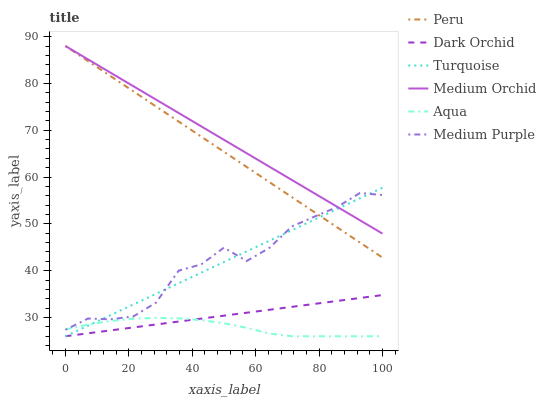Does Aqua have the minimum area under the curve?
Answer yes or no. Yes. Does Medium Orchid have the maximum area under the curve?
Answer yes or no. Yes. Does Medium Orchid have the minimum area under the curve?
Answer yes or no. No. Does Aqua have the maximum area under the curve?
Answer yes or no. No. Is Turquoise the smoothest?
Answer yes or no. Yes. Is Medium Purple the roughest?
Answer yes or no. Yes. Is Medium Orchid the smoothest?
Answer yes or no. No. Is Medium Orchid the roughest?
Answer yes or no. No. Does Turquoise have the lowest value?
Answer yes or no. Yes. Does Medium Orchid have the lowest value?
Answer yes or no. No. Does Peru have the highest value?
Answer yes or no. Yes. Does Aqua have the highest value?
Answer yes or no. No. Is Dark Orchid less than Peru?
Answer yes or no. Yes. Is Medium Orchid greater than Dark Orchid?
Answer yes or no. Yes. Does Turquoise intersect Medium Purple?
Answer yes or no. Yes. Is Turquoise less than Medium Purple?
Answer yes or no. No. Is Turquoise greater than Medium Purple?
Answer yes or no. No. Does Dark Orchid intersect Peru?
Answer yes or no. No. 